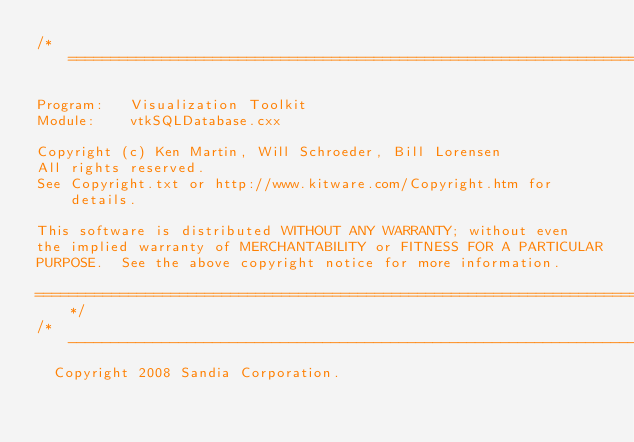Convert code to text. <code><loc_0><loc_0><loc_500><loc_500><_C++_>/*=========================================================================

Program:   Visualization Toolkit
Module:    vtkSQLDatabase.cxx

Copyright (c) Ken Martin, Will Schroeder, Bill Lorensen
All rights reserved.
See Copyright.txt or http://www.kitware.com/Copyright.htm for details.

This software is distributed WITHOUT ANY WARRANTY; without even
the implied warranty of MERCHANTABILITY or FITNESS FOR A PARTICULAR
PURPOSE.  See the above copyright notice for more information.

=========================================================================*/
/*-------------------------------------------------------------------------
  Copyright 2008 Sandia Corporation.</code> 